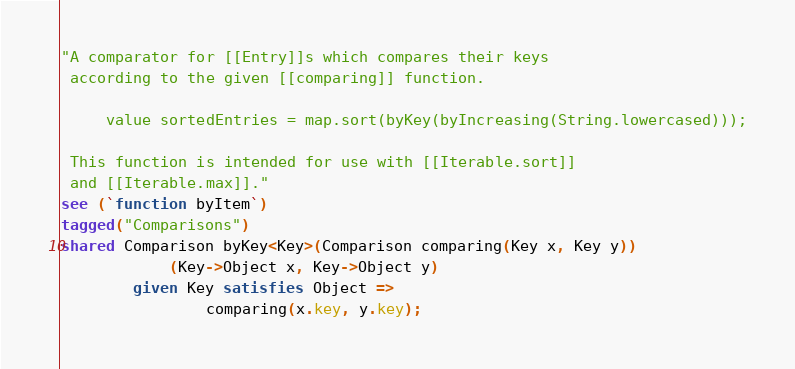Convert code to text. <code><loc_0><loc_0><loc_500><loc_500><_Ceylon_>"A comparator for [[Entry]]s which compares their keys 
 according to the given [[comparing]] function.
 
     value sortedEntries = map.sort(byKey(byIncreasing(String.lowercased)));
 
 This function is intended for use with [[Iterable.sort]]
 and [[Iterable.max]]."
see (`function byItem`)
tagged("Comparisons")
shared Comparison byKey<Key>(Comparison comparing(Key x, Key y))
            (Key->Object x, Key->Object y) 
        given Key satisfies Object =>
                comparing(x.key, y.key);</code> 